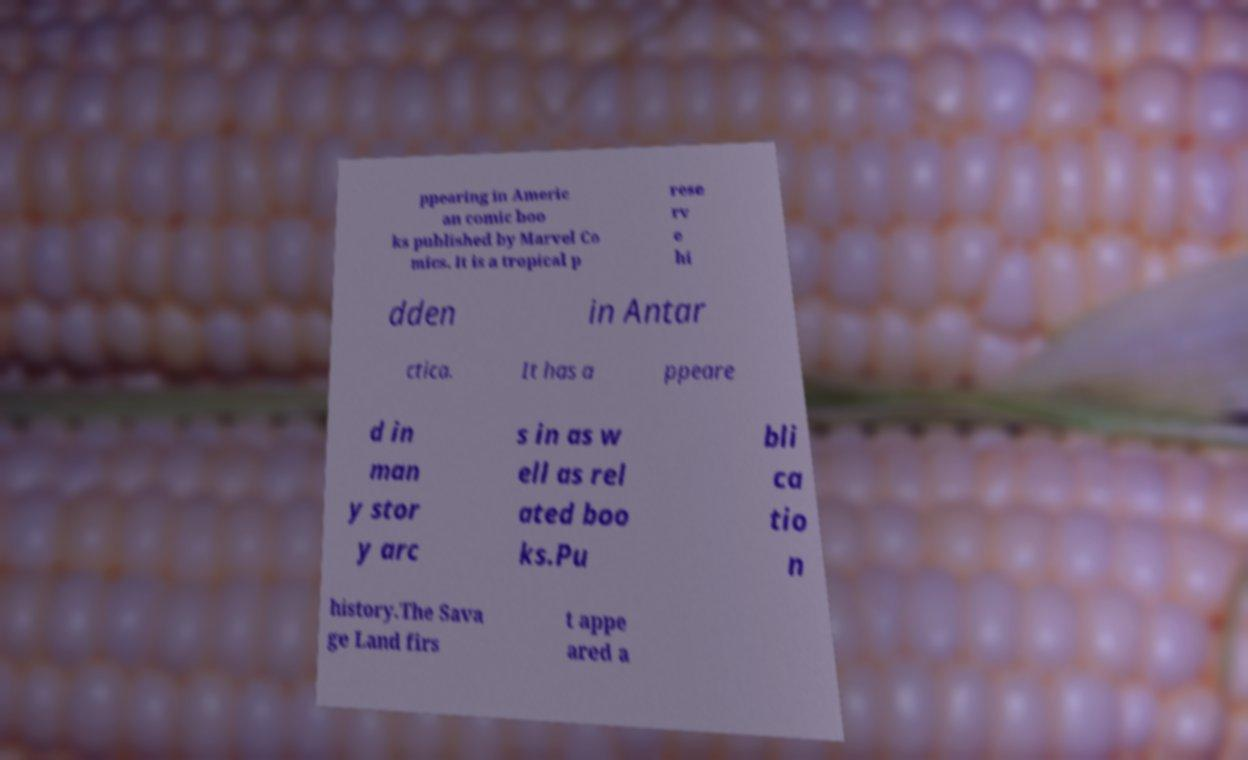Can you read and provide the text displayed in the image?This photo seems to have some interesting text. Can you extract and type it out for me? ppearing in Americ an comic boo ks published by Marvel Co mics. It is a tropical p rese rv e hi dden in Antar ctica. It has a ppeare d in man y stor y arc s in as w ell as rel ated boo ks.Pu bli ca tio n history.The Sava ge Land firs t appe ared a 